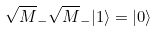Convert formula to latex. <formula><loc_0><loc_0><loc_500><loc_500>\sqrt { M } _ { - } \sqrt { M } _ { - } | 1 \rangle = | 0 \rangle</formula> 